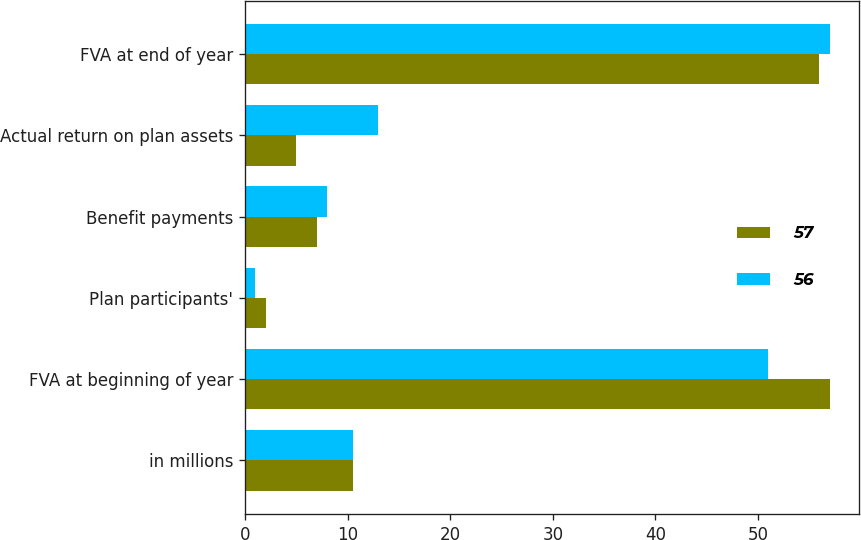Convert chart. <chart><loc_0><loc_0><loc_500><loc_500><stacked_bar_chart><ecel><fcel>in millions<fcel>FVA at beginning of year<fcel>Plan participants'<fcel>Benefit payments<fcel>Actual return on plan assets<fcel>FVA at end of year<nl><fcel>57<fcel>10.5<fcel>57<fcel>2<fcel>7<fcel>5<fcel>56<nl><fcel>56<fcel>10.5<fcel>51<fcel>1<fcel>8<fcel>13<fcel>57<nl></chart> 